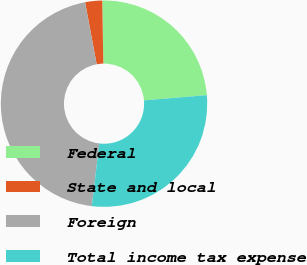Convert chart. <chart><loc_0><loc_0><loc_500><loc_500><pie_chart><fcel>Federal<fcel>State and local<fcel>Foreign<fcel>Total income tax expense<nl><fcel>23.96%<fcel>2.66%<fcel>45.17%<fcel>28.21%<nl></chart> 